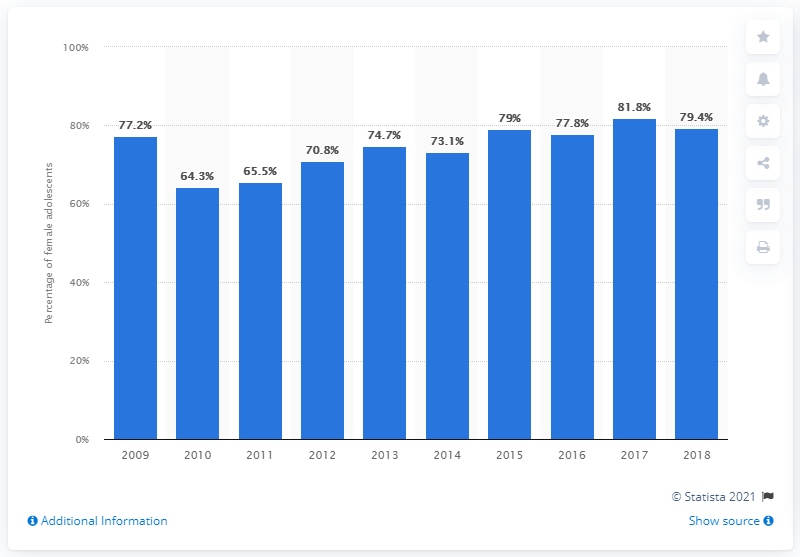Point out several critical features in this image. In 2018, 79.4% of girls aged 11 to 14 in Spain were immunized against HPV, according to data released by the Spanish National Health Institute. 